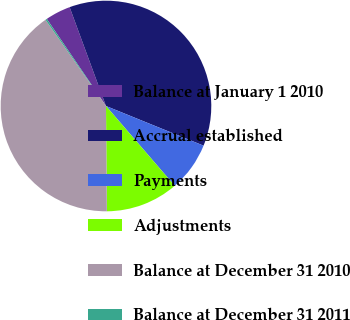Convert chart to OTSL. <chart><loc_0><loc_0><loc_500><loc_500><pie_chart><fcel>Balance at January 1 2010<fcel>Accrual established<fcel>Payments<fcel>Adjustments<fcel>Balance at December 31 2010<fcel>Balance at December 31 2011<nl><fcel>3.89%<fcel>36.75%<fcel>7.54%<fcel>11.18%<fcel>40.39%<fcel>0.24%<nl></chart> 